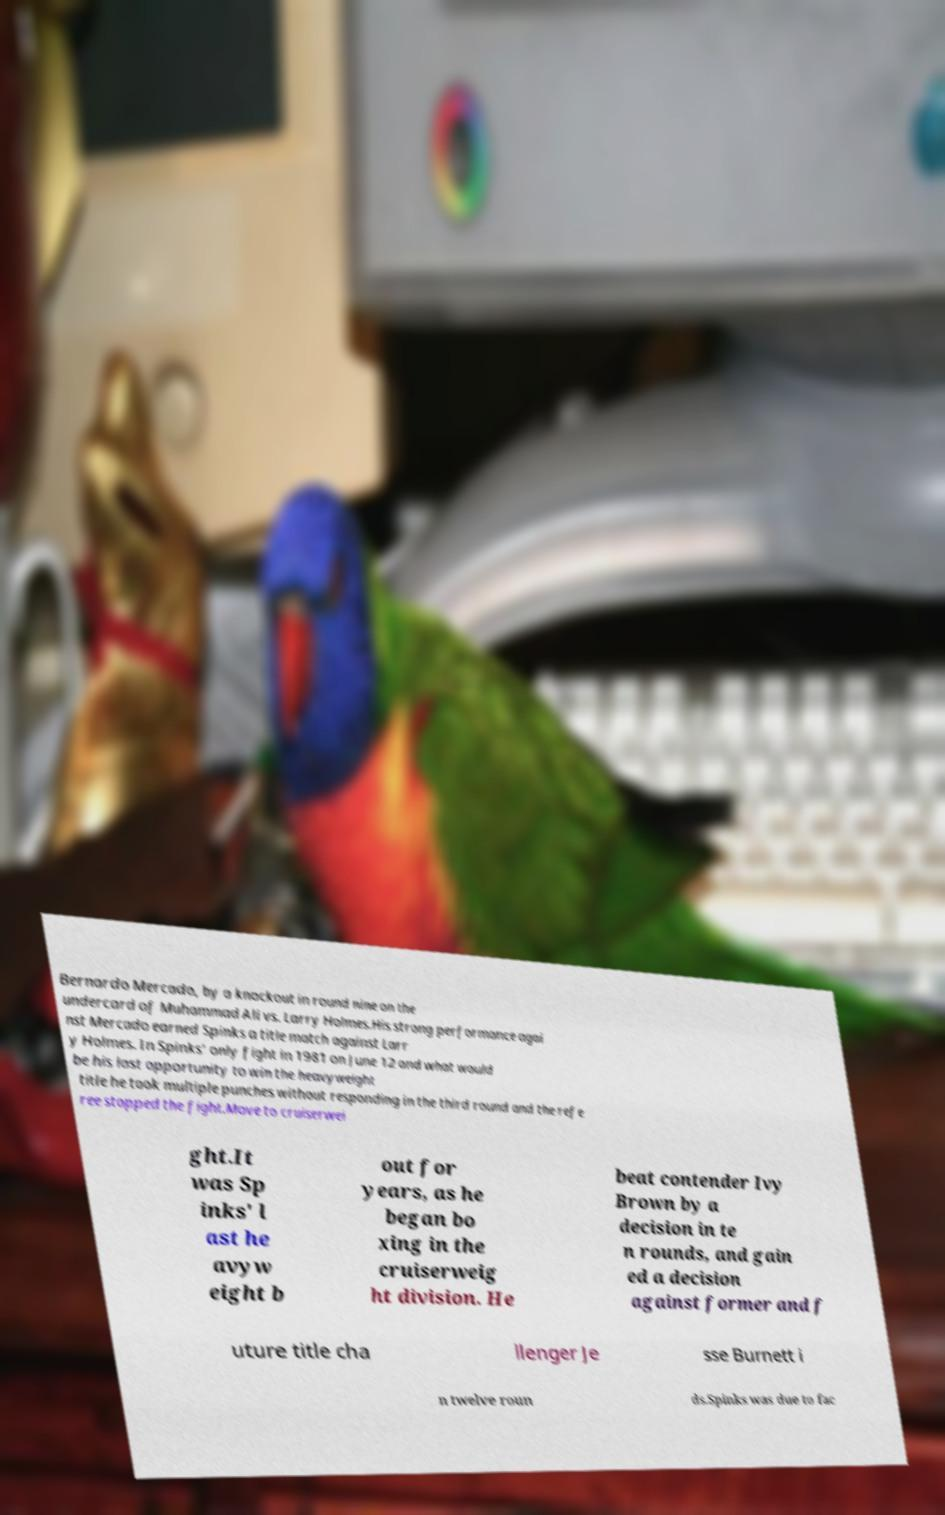I need the written content from this picture converted into text. Can you do that? Bernardo Mercado, by a knockout in round nine on the undercard of Muhammad Ali vs. Larry Holmes.His strong performance agai nst Mercado earned Spinks a title match against Larr y Holmes. In Spinks' only fight in 1981 on June 12 and what would be his last opportunity to win the heavyweight title he took multiple punches without responding in the third round and the refe ree stopped the fight.Move to cruiserwei ght.It was Sp inks' l ast he avyw eight b out for years, as he began bo xing in the cruiserweig ht division. He beat contender Ivy Brown by a decision in te n rounds, and gain ed a decision against former and f uture title cha llenger Je sse Burnett i n twelve roun ds.Spinks was due to fac 